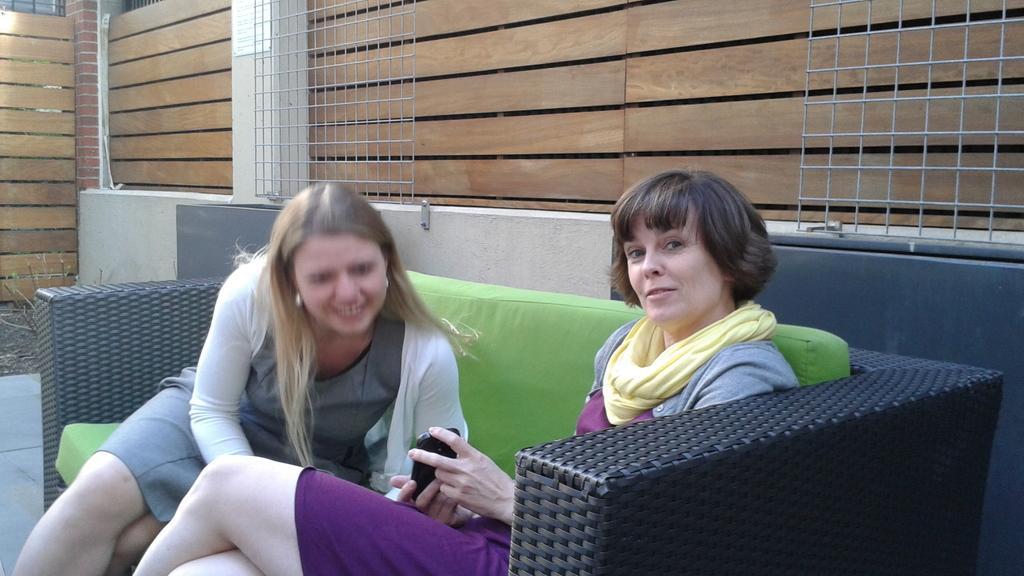Can you describe this image briefly? In this picture I can observe two women sitting in the sofa. Both of them are smiling. The sofa is in black color. In the background I can observe wooden wall. 